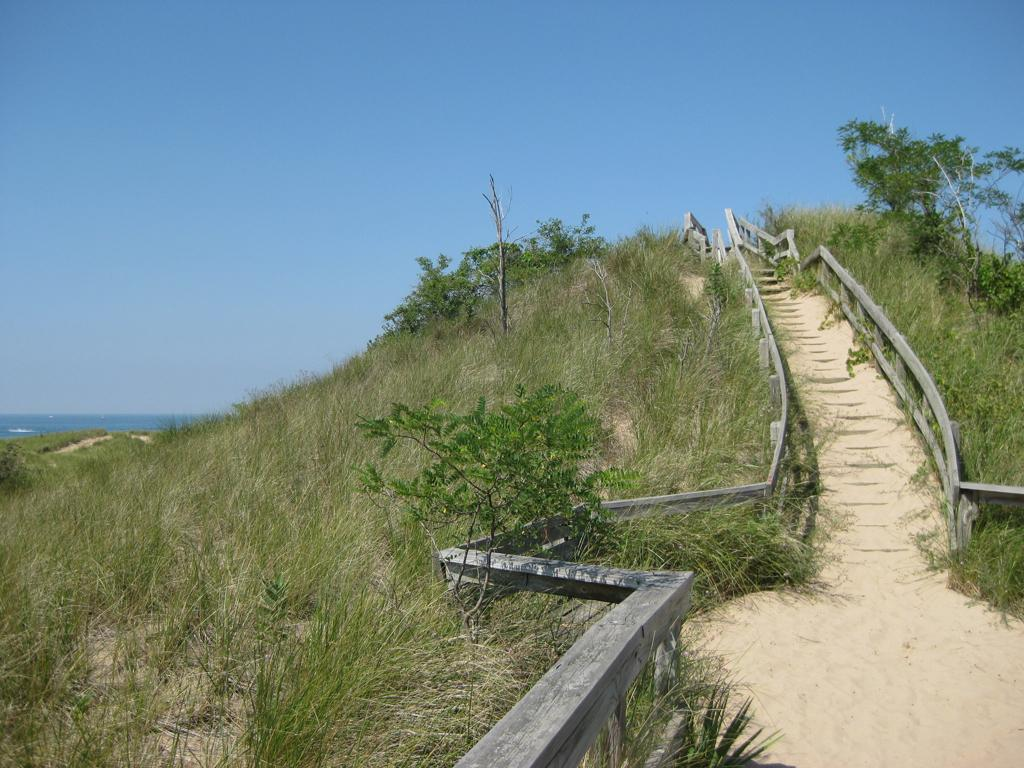What type of vegetation can be seen in the image? There are plants in the image. What is on the ground in the image? There is grass on the ground in the image. What can be seen in the background of the image? Water is visible in the image. What color is the sky in the image? The sky is blue in the image. What type of barrier is present on both sides of a path in the image? There is a wooden fence on both sides of a path in the image. What type of shoe is placed on the tray in the image? There is no shoe or tray present in the image. What type of knife is used to cut the wooden fence in the image? There is no knife or action of cutting the wooden fence in the image. 